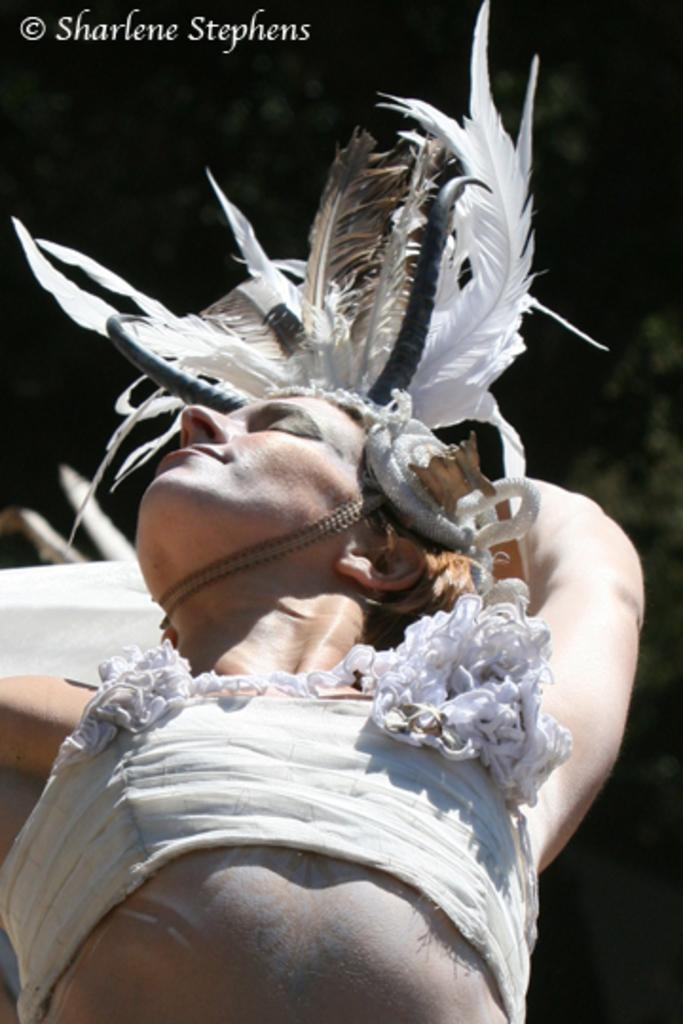Who or what is the main subject in the image? There is a person in the image. What is the person wearing? The person is wearing a costume. Can you describe the background of the image? The background of the image is dark. How many clouds can be seen in the image? There are no clouds visible in the image, as the background is dark. What type of pig is present in the image? There is no pig present in the image; it features a person wearing a costume. 